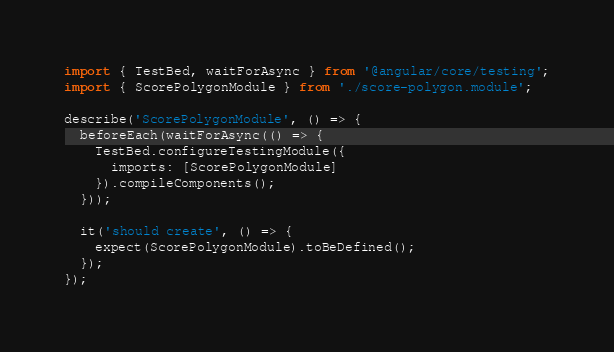<code> <loc_0><loc_0><loc_500><loc_500><_TypeScript_>import { TestBed, waitForAsync } from '@angular/core/testing';
import { ScorePolygonModule } from './score-polygon.module';

describe('ScorePolygonModule', () => {
  beforeEach(waitForAsync(() => {
    TestBed.configureTestingModule({
      imports: [ScorePolygonModule]
    }).compileComponents();
  }));

  it('should create', () => {
    expect(ScorePolygonModule).toBeDefined();
  });
});
</code> 